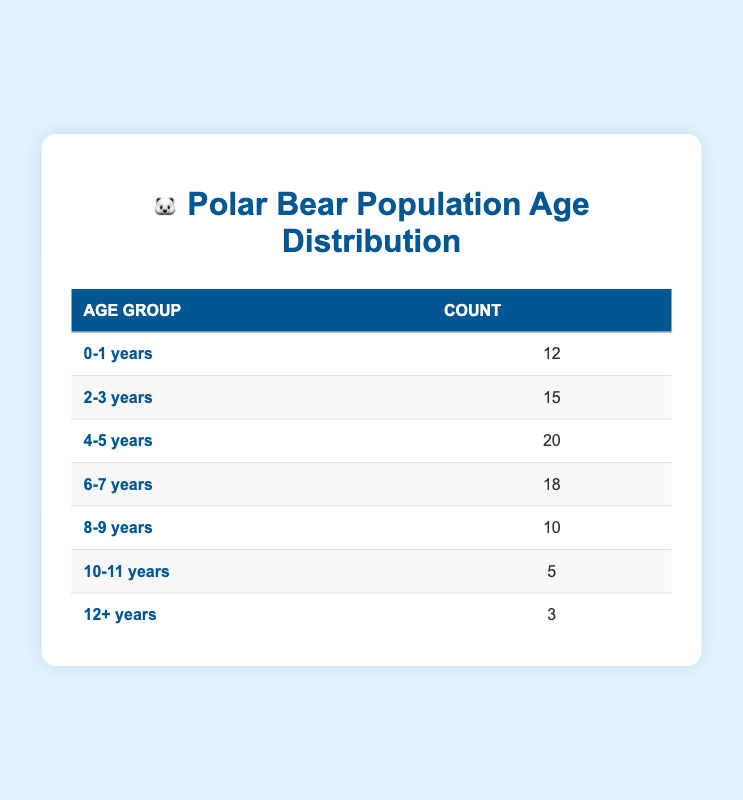What is the count of polar bears in the age group 4-5 years? The table specifies that the count of polar bears in the age group 4-5 years is listed directly under the 'Count' column for that row.
Answer: 20 How many polar bears belong to the age group 10-11 years? The table shows that the count for the age group 10-11 years is present in the corresponding row, which states that there are 5 polar bears in this age group.
Answer: 5 What age group has the highest number of polar bears? By reviewing the 'Count' column for all age groups, the age group 4-5 years has the highest count of 20 polar bears, more than any other age group.
Answer: 4-5 years Is the number of polar bears in the age group 12+ years greater than in the age group 8-9 years? The count for 12+ years is 3, while the count for 8-9 years is 10. Since 3 is less than 10, the statement is false.
Answer: No What is the total number of polar bears in the age groups ranging from 0-1 years to 6-7 years? To find the total, add the counts for the age groups: 12 (0-1) + 15 (2-3) + 20 (4-5) + 18 (6-7) = 65. Thus, the total is 65 polar bears in these age groups.
Answer: 65 What percentage of polar bears are in the age group 2-3 years? The total count of polar bears is 83 (sum of all counts). The count for 2-3 years is 15. The percentage is calculated as (15/83) * 100, which approximately equals 18.07%. Therefore, about 18% of the polar bears are in this age group.
Answer: 18% What is the difference in count between the age groups 4-5 years and 10-11 years? The count for 4-5 years is 20 and for 10-11 years is 5. Thus, the difference in count is calculated as 20 - 5 = 15.
Answer: 15 Are there more polar bears in the age group 0-1 years than in the age group 12+ years? The count for 0-1 years is 12 and for 12+ years is 3. Since 12 is greater than 3, the statement is true.
Answer: Yes What is the average count of polar bears across all age groups? To find the average, sum all counts: 12 + 15 + 20 + 18 + 10 + 5 + 3 = 83. There are 7 age groups, so the average is 83 / 7, which is approximately 11.86.
Answer: 11.86 